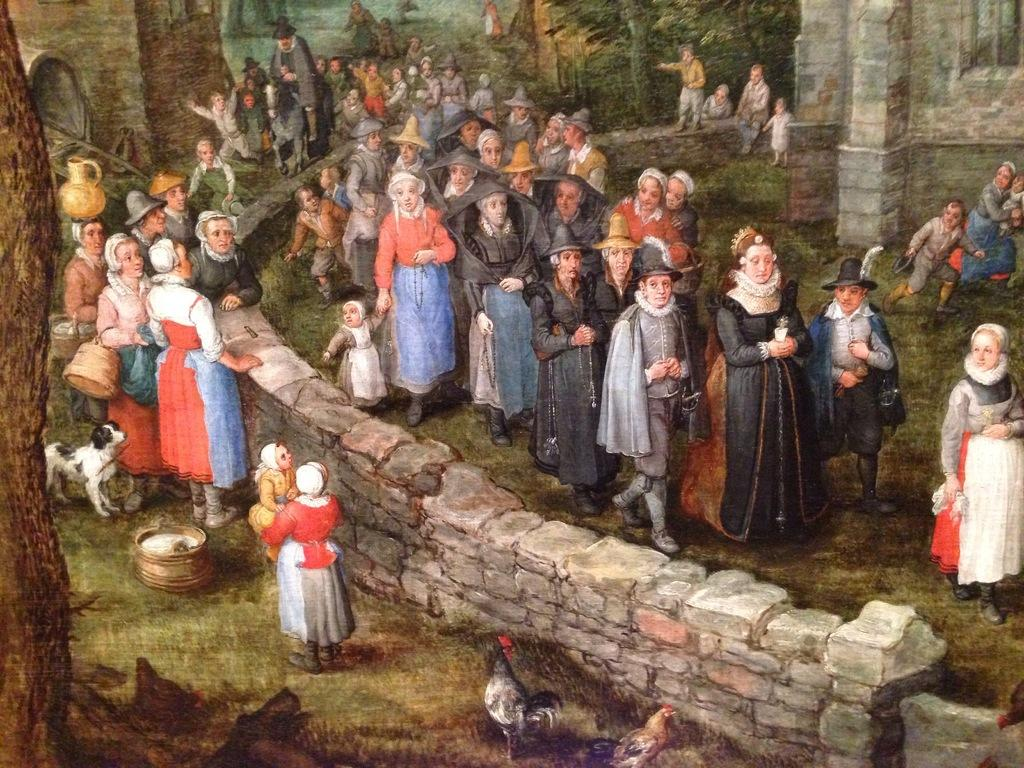What types of animals are present in the image? There are chickens and a dog depicted in the image. What other living beings are present in the image? There are people depicted in the image. What can be seen in the background of the image? There are trees depicted in the background of the image. What type of bells can be heard ringing in the garden in the image? There is no mention of bells or a garden in the image, so it is not possible to answer that question. 